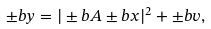<formula> <loc_0><loc_0><loc_500><loc_500>\pm b y = | \pm b A \pm b x | ^ { 2 } + \pm b v ,</formula> 